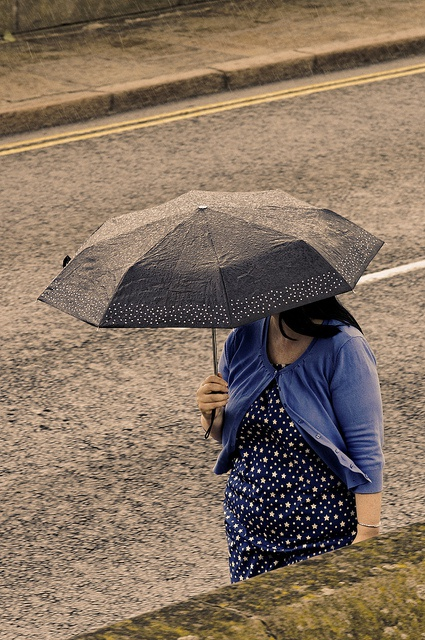Describe the objects in this image and their specific colors. I can see people in black, navy, and gray tones and umbrella in black and gray tones in this image. 